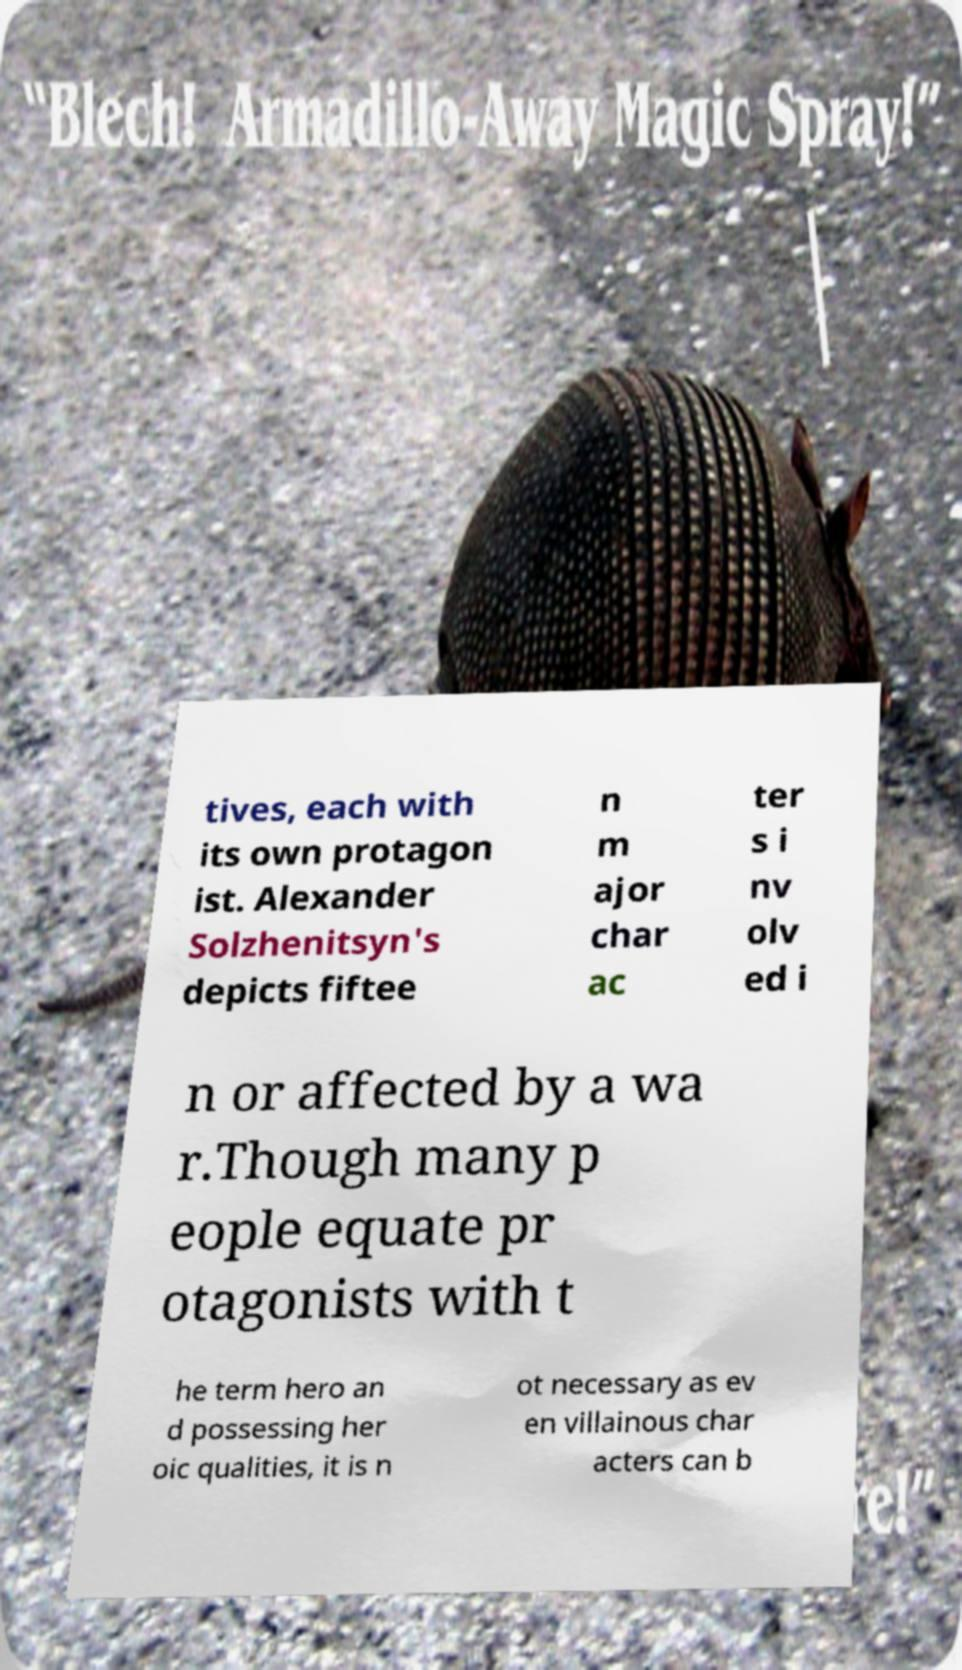What messages or text are displayed in this image? I need them in a readable, typed format. tives, each with its own protagon ist. Alexander Solzhenitsyn's depicts fiftee n m ajor char ac ter s i nv olv ed i n or affected by a wa r.Though many p eople equate pr otagonists with t he term hero an d possessing her oic qualities, it is n ot necessary as ev en villainous char acters can b 